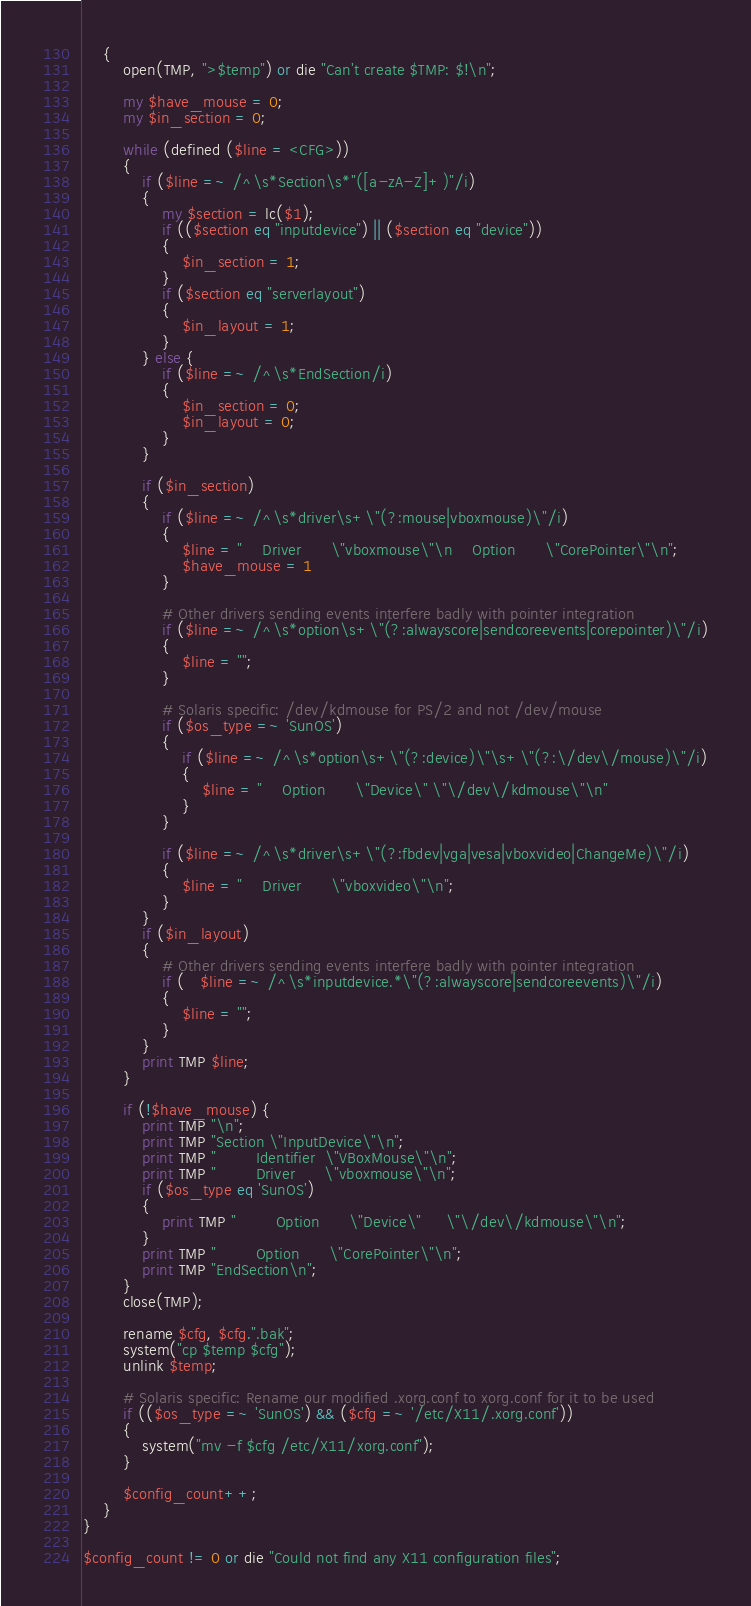Convert code to text. <code><loc_0><loc_0><loc_500><loc_500><_Perl_>    {
        open(TMP, ">$temp") or die "Can't create $TMP: $!\n";

        my $have_mouse = 0;
        my $in_section = 0;

        while (defined ($line = <CFG>))
        {
            if ($line =~ /^\s*Section\s*"([a-zA-Z]+)"/i)
            {
                my $section = lc($1);
                if (($section eq "inputdevice") || ($section eq "device"))
                {
                    $in_section = 1;
                }
                if ($section eq "serverlayout")
                {
                    $in_layout = 1;
                }
            } else {
                if ($line =~ /^\s*EndSection/i)
                {
                    $in_section = 0;
                    $in_layout = 0;
                }
            }

            if ($in_section)
            {
                if ($line =~ /^\s*driver\s+\"(?:mouse|vboxmouse)\"/i)
                {
                    $line = "    Driver      \"vboxmouse\"\n    Option      \"CorePointer\"\n";
                    $have_mouse = 1
                }

                # Other drivers sending events interfere badly with pointer integration
                if ($line =~ /^\s*option\s+\"(?:alwayscore|sendcoreevents|corepointer)\"/i)
                {
                    $line = "";
                }

                # Solaris specific: /dev/kdmouse for PS/2 and not /dev/mouse
                if ($os_type =~ 'SunOS')
                {
                    if ($line =~ /^\s*option\s+\"(?:device)\"\s+\"(?:\/dev\/mouse)\"/i)
                    {
                        $line = "    Option      \"Device\" \"\/dev\/kdmouse\"\n"
                    }
                }

                if ($line =~ /^\s*driver\s+\"(?:fbdev|vga|vesa|vboxvideo|ChangeMe)\"/i)
                {
                    $line = "    Driver      \"vboxvideo\"\n";
                }
            }
            if ($in_layout)
            {
                # Other drivers sending events interfere badly with pointer integration
                if (   $line =~ /^\s*inputdevice.*\"(?:alwayscore|sendcoreevents)\"/i)
                {
                    $line = "";
                }
            }
            print TMP $line;
        }

        if (!$have_mouse) {
            print TMP "\n";
            print TMP "Section \"InputDevice\"\n";
            print TMP "        Identifier  \"VBoxMouse\"\n";
            print TMP "        Driver      \"vboxmouse\"\n";
            if ($os_type eq 'SunOS')
            {
                print TMP "        Option      \"Device\"     \"\/dev\/kdmouse\"\n";
            }
            print TMP "        Option      \"CorePointer\"\n";
            print TMP "EndSection\n";
        }
        close(TMP);

        rename $cfg, $cfg.".bak";
        system("cp $temp $cfg");
        unlink $temp;

        # Solaris specific: Rename our modified .xorg.conf to xorg.conf for it to be used
        if (($os_type =~ 'SunOS') && ($cfg =~ '/etc/X11/.xorg.conf'))
        {
            system("mv -f $cfg /etc/X11/xorg.conf");
        }

        $config_count++;
    }
}

$config_count != 0 or die "Could not find any X11 configuration files";
</code> 